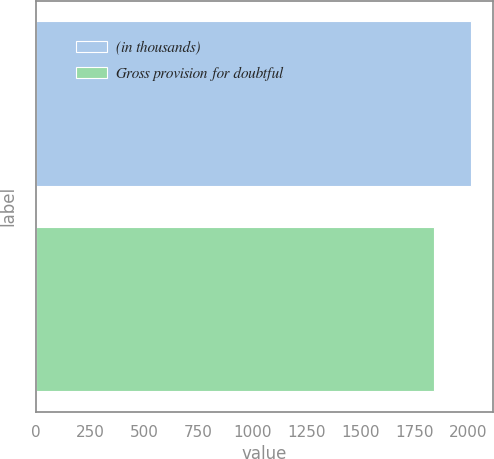<chart> <loc_0><loc_0><loc_500><loc_500><bar_chart><fcel>(in thousands)<fcel>Gross provision for doubtful<nl><fcel>2013<fcel>1841<nl></chart> 